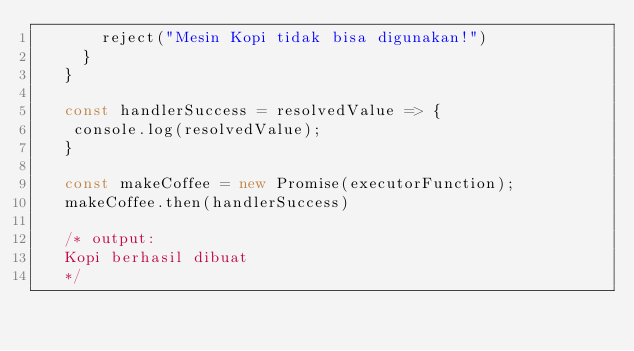Convert code to text. <code><loc_0><loc_0><loc_500><loc_500><_JavaScript_>       reject("Mesin Kopi tidak bisa digunakan!")
     }
   }
   
   const handlerSuccess = resolvedValue => {
    console.log(resolvedValue);
   }
   
   const makeCoffee = new Promise(executorFunction);
   makeCoffee.then(handlerSuccess)
   
   /* output:
   Kopi berhasil dibuat
   */</code> 